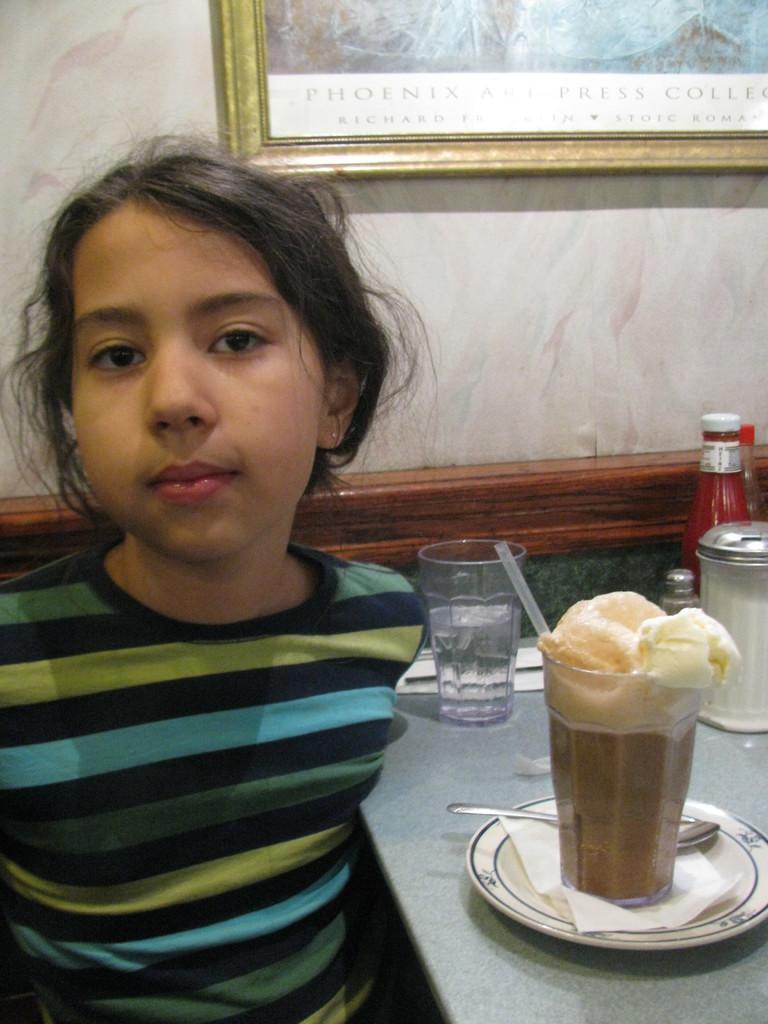Could you give a brief overview of what you see in this image? This image consists of a girl. On the right, there is a table on which there are glasses and a ketchup bottle along with a plate and spoon. In the background, there is a frame hanged on the wall. 